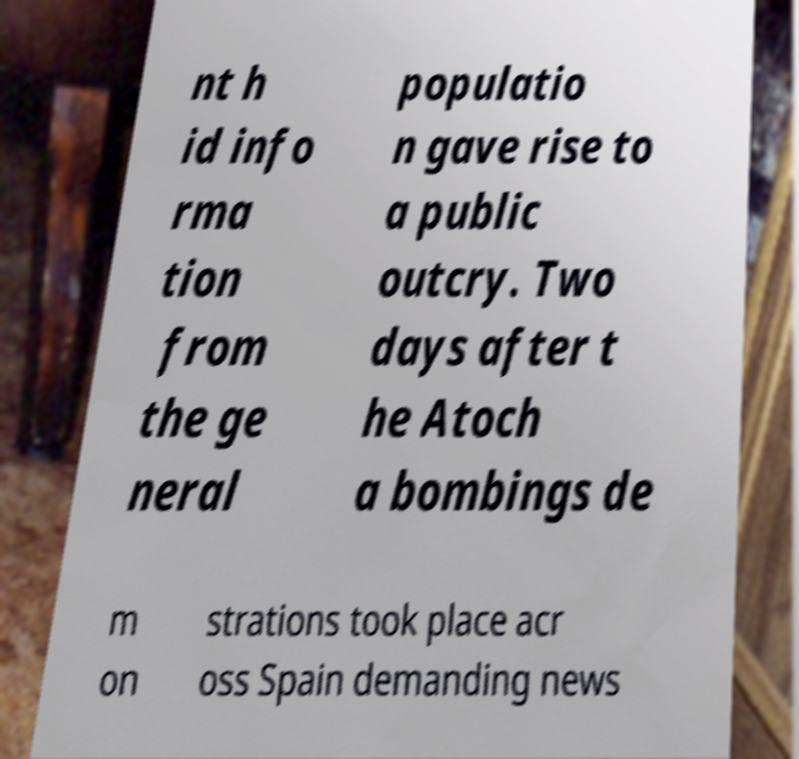Can you accurately transcribe the text from the provided image for me? nt h id info rma tion from the ge neral populatio n gave rise to a public outcry. Two days after t he Atoch a bombings de m on strations took place acr oss Spain demanding news 